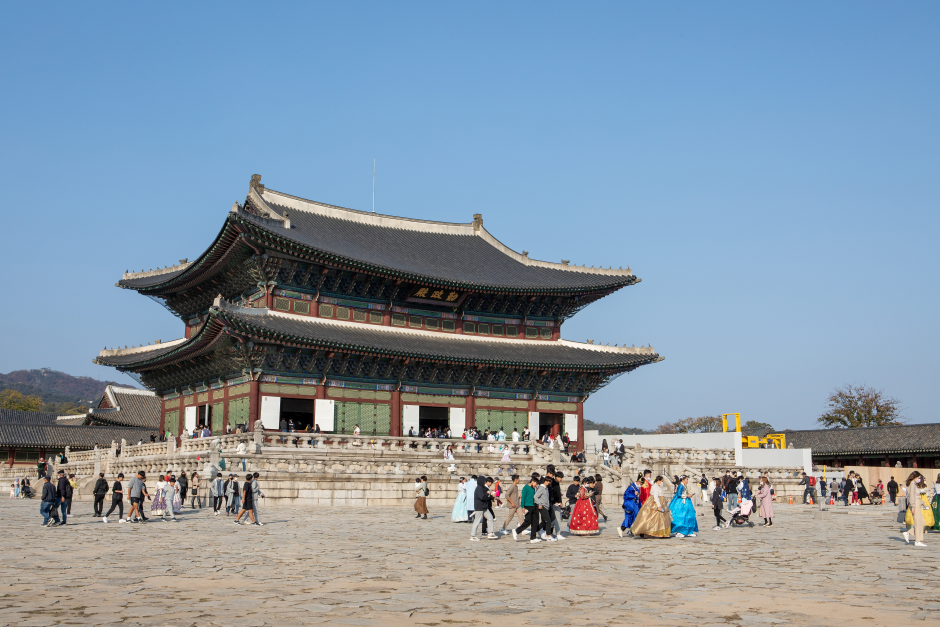Can you tell me more about the historical significance of this palace? Gyeongbokgung Palace, built in 1395 during the Joseon Dynasty, served as the main royal palace and is one of the Five Grand Palaces. It played a crucial role in Korean history as the seat of royal power and administration. The palace has endured various reconstructions, especially after being destroyed during the Japanese invasions of Korea (1592–1598). Today, it stands as a symbol of national pride and is an important cultural and historical site, attracting numerous visitors who come to admire its beauty and learn about Korea's regal past. What kind of activities can tourists enjoy here? Visitors can engage in a range of activities at Gyeongbokgung Palace. One popular activity is participating in the changing of the guard ceremony, a colorful and traditional event held multiple times a day. Tourists can also explore the National Palace Museum and the National Folk Museum, both located within the palace grounds, offering deeper insights into Korean history and culture. Additionally, many enjoy renting and wearing traditional hanbok costumes, which provides a unique photo opportunity and an immersive cultural experience as they stroll through the palace premises. 